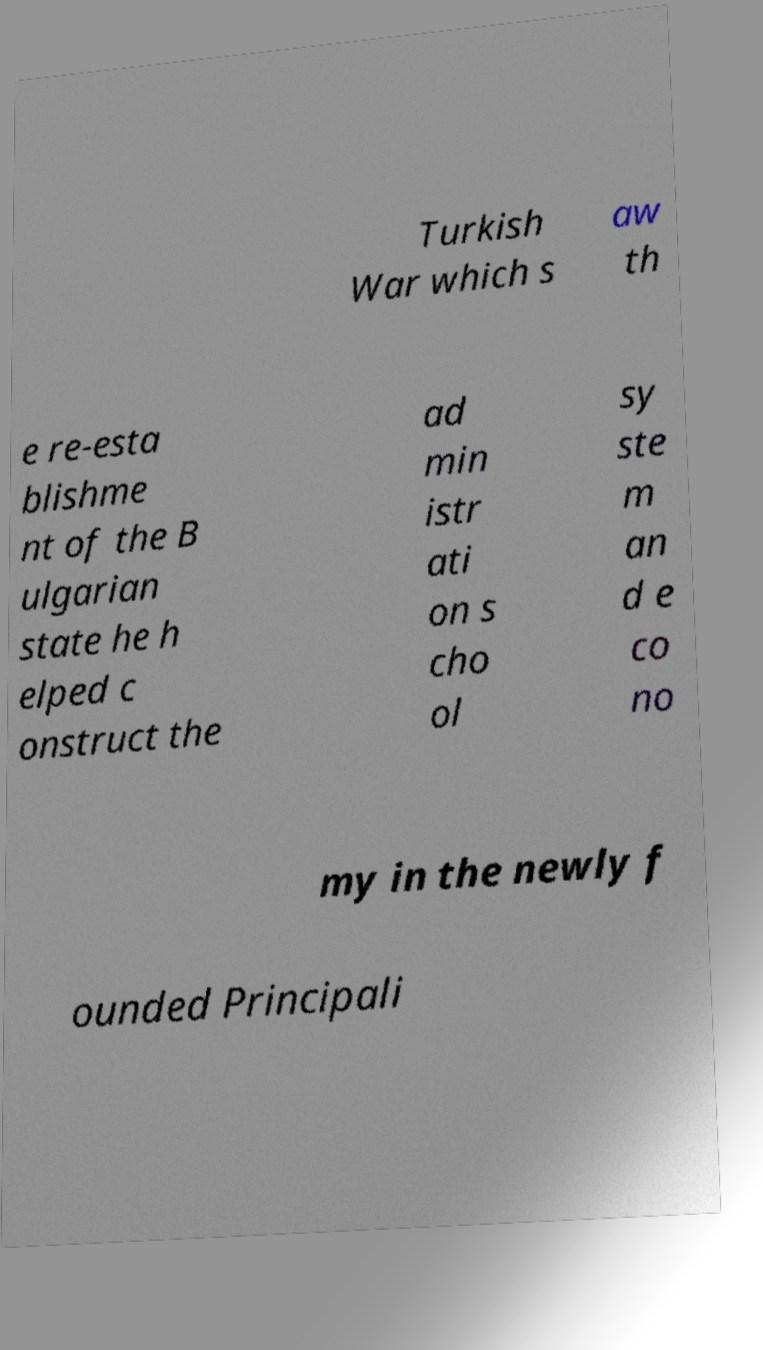Can you read and provide the text displayed in the image?This photo seems to have some interesting text. Can you extract and type it out for me? Turkish War which s aw th e re-esta blishme nt of the B ulgarian state he h elped c onstruct the ad min istr ati on s cho ol sy ste m an d e co no my in the newly f ounded Principali 